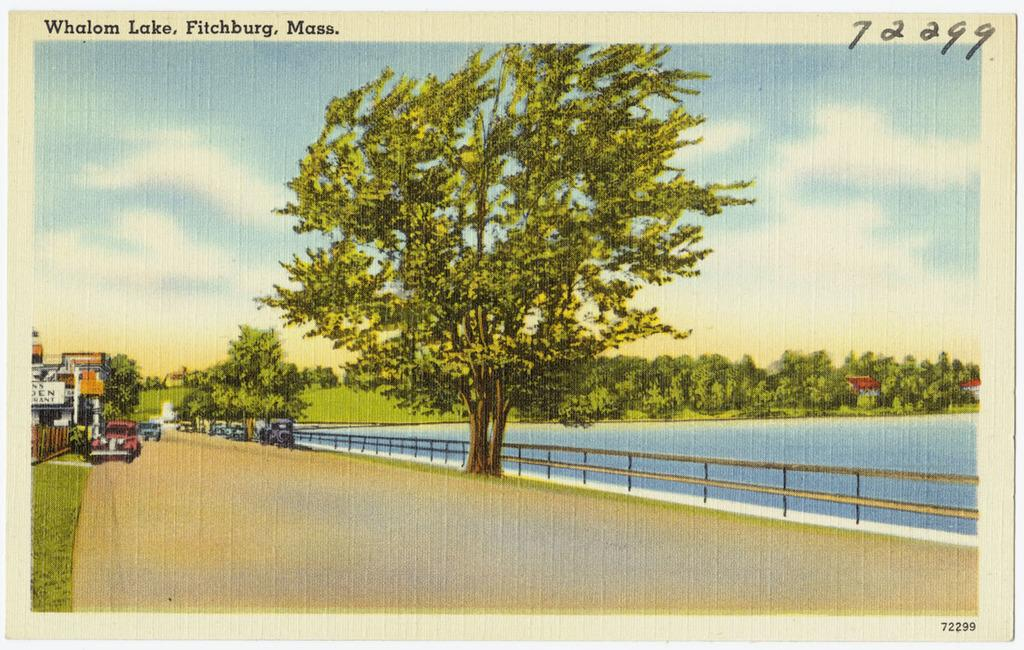What is depicted on the poster in the image? The poster contains trees, cars, houses, and grass. What is visible at the bottom of the image? There is water, railing, and text visible at the bottom of the image. What is visible at the top of the image? There is sky, clouds, and text visible at the top of the image. Can you see a band playing music in the image? There is no band playing music in the image. Are there any deer visible in the image? There are no deer present in the image. 